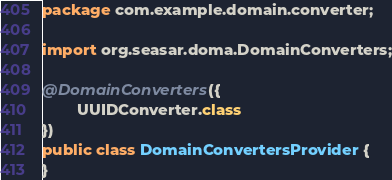<code> <loc_0><loc_0><loc_500><loc_500><_Java_>package com.example.domain.converter;

import org.seasar.doma.DomainConverters;

@DomainConverters({
        UUIDConverter.class
})
public class DomainConvertersProvider {
}
</code> 